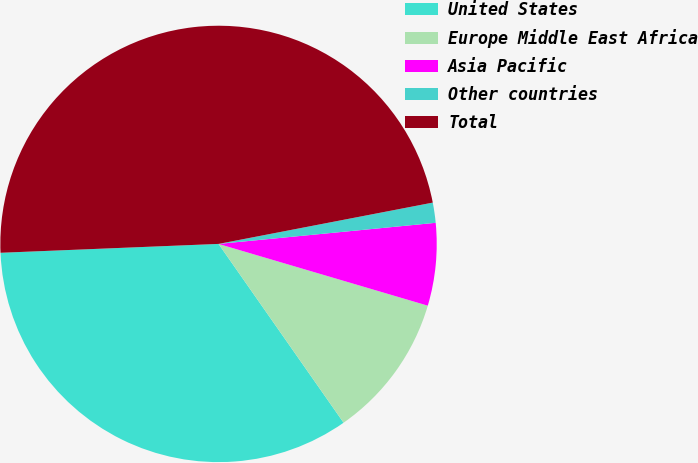Convert chart. <chart><loc_0><loc_0><loc_500><loc_500><pie_chart><fcel>United States<fcel>Europe Middle East Africa<fcel>Asia Pacific<fcel>Other countries<fcel>Total<nl><fcel>34.07%<fcel>10.72%<fcel>6.11%<fcel>1.49%<fcel>47.62%<nl></chart> 